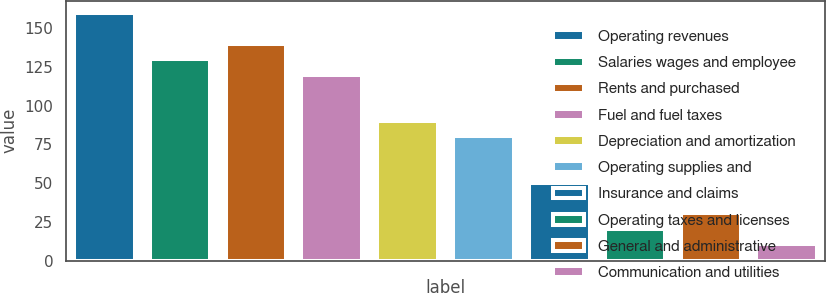Convert chart. <chart><loc_0><loc_0><loc_500><loc_500><bar_chart><fcel>Operating revenues<fcel>Salaries wages and employee<fcel>Rents and purchased<fcel>Fuel and fuel taxes<fcel>Depreciation and amortization<fcel>Operating supplies and<fcel>Insurance and claims<fcel>Operating taxes and licenses<fcel>General and administrative<fcel>Communication and utilities<nl><fcel>159.58<fcel>129.79<fcel>139.72<fcel>119.86<fcel>90.07<fcel>80.14<fcel>50.35<fcel>20.56<fcel>30.49<fcel>10.63<nl></chart> 